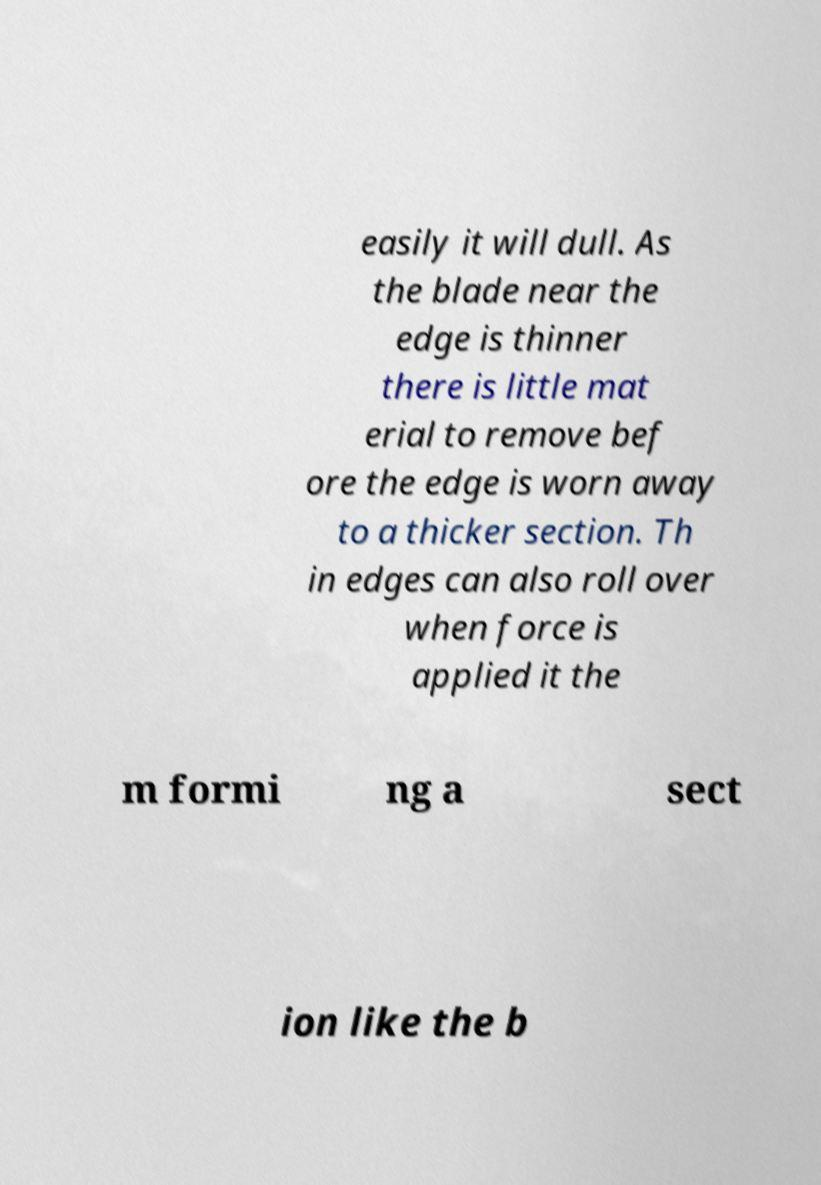I need the written content from this picture converted into text. Can you do that? easily it will dull. As the blade near the edge is thinner there is little mat erial to remove bef ore the edge is worn away to a thicker section. Th in edges can also roll over when force is applied it the m formi ng a sect ion like the b 